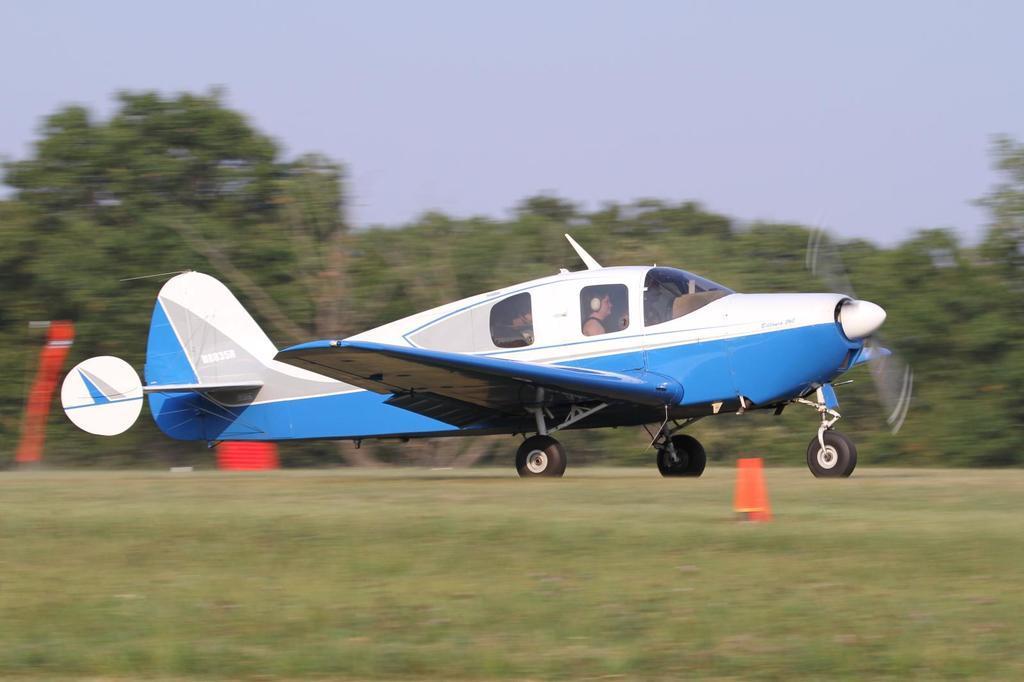Describe this image in one or two sentences. In the center of the picture there is an aircraft, on the runway. In the aircraft there is a person. In the background there are trees. In the foreground there is grass. 